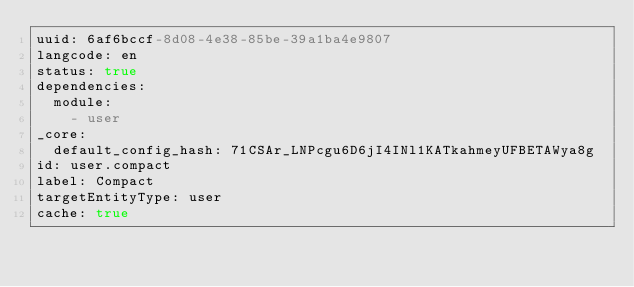<code> <loc_0><loc_0><loc_500><loc_500><_YAML_>uuid: 6af6bccf-8d08-4e38-85be-39a1ba4e9807
langcode: en
status: true
dependencies:
  module:
    - user
_core:
  default_config_hash: 71CSAr_LNPcgu6D6jI4INl1KATkahmeyUFBETAWya8g
id: user.compact
label: Compact
targetEntityType: user
cache: true
</code> 